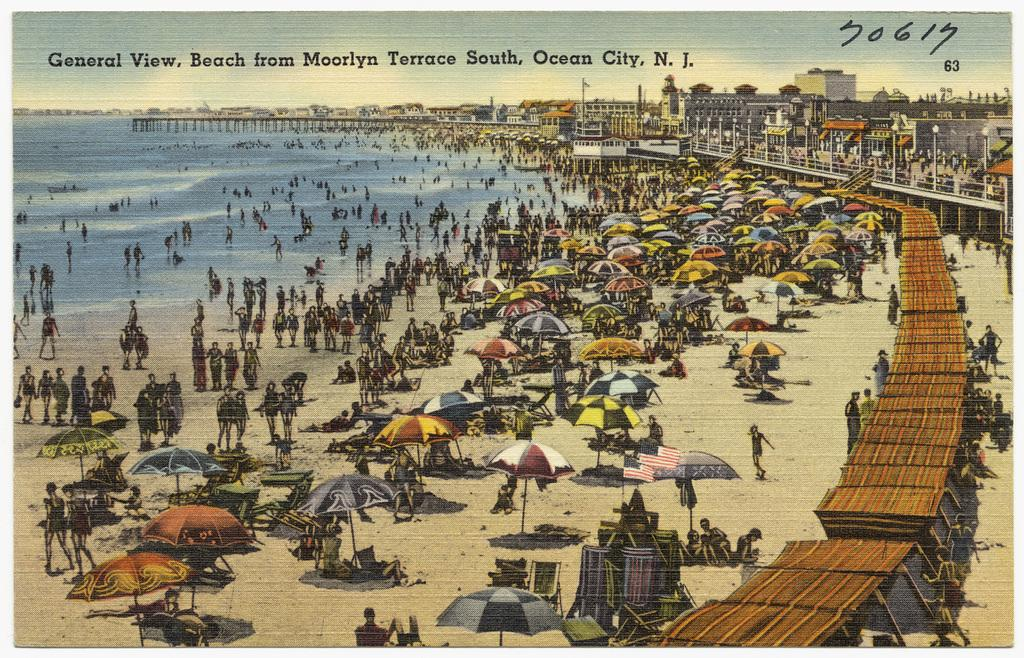Provide a one-sentence caption for the provided image. A cartoon drawing of a beach from Moorlyn Terrace South, Ocean City, New Jersey. 